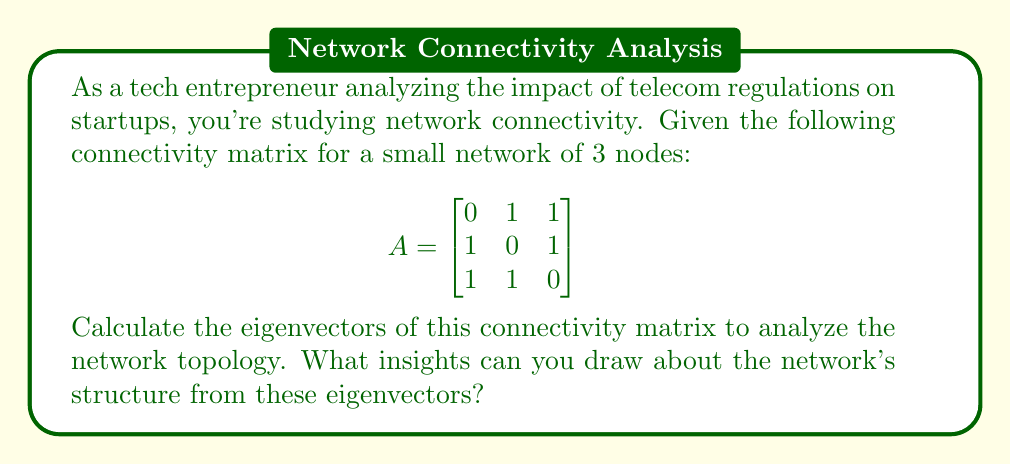Show me your answer to this math problem. To find the eigenvectors of the connectivity matrix A, we need to follow these steps:

1) First, find the eigenvalues by solving the characteristic equation:
   $det(A - \lambda I) = 0$

   $$ \begin{vmatrix}
   -\lambda & 1 & 1 \\
   1 & -\lambda & 1 \\
   1 & 1 & -\lambda
   \end{vmatrix} = 0 $$

   Expanding this determinant:
   $-\lambda^3 + 3\lambda + 2 = 0$

   Solving this equation, we get:
   $\lambda_1 = 2$, $\lambda_2 = \lambda_3 = -1$

2) Now, for each eigenvalue, we solve $(A - \lambda I)v = 0$ to find the corresponding eigenvector:

   For $\lambda_1 = 2$:
   $$ \begin{bmatrix}
   -2 & 1 & 1 \\
   1 & -2 & 1 \\
   1 & 1 & -2
   \end{bmatrix} \begin{bmatrix} v_1 \\ v_2 \\ v_3 \end{bmatrix} = \begin{bmatrix} 0 \\ 0 \\ 0 \end{bmatrix} $$

   Solving this system, we get: $v_1 = v_2 = v_3$
   Normalizing, the eigenvector is: $v_1 = \frac{1}{\sqrt{3}}[1, 1, 1]^T$

   For $\lambda_2 = \lambda_3 = -1$:
   $$ \begin{bmatrix}
   1 & 1 & 1 \\
   1 & 1 & 1 \\
   1 & 1 & 1
   \end{bmatrix} \begin{bmatrix} v_1 \\ v_2 \\ v_3 \end{bmatrix} = \begin{bmatrix} 0 \\ 0 \\ 0 \end{bmatrix} $$

   This system has infinitely many solutions. Two orthogonal eigenvectors are:
   $v_2 = \frac{1}{\sqrt{2}}[1, -1, 0]^T$ and $v_3 = \frac{1}{\sqrt{6}}[1, 1, -2]^T$

3) Insights from eigenvectors:
   - The first eigenvector $v_1$ corresponds to the largest eigenvalue and has equal components, indicating that all nodes have equal importance in the network.
   - The other two eigenvectors $v_2$ and $v_3$ correspond to the negative eigenvalue and represent different ways the network can be partitioned.
   - The presence of only one positive eigenvalue suggests that the network has one dominant connected component.
   - The symmetry in the eigenvectors reflects the symmetry in the network topology.
Answer: The eigenvectors of the connectivity matrix are:

$v_1 = \frac{1}{\sqrt{3}}[1, 1, 1]^T$
$v_2 = \frac{1}{\sqrt{2}}[1, -1, 0]^T$
$v_3 = \frac{1}{\sqrt{6}}[1, 1, -2]^T$

These eigenvectors indicate a fully connected network with symmetric connections between all nodes, suggesting equal importance of all nodes in the network topology. 